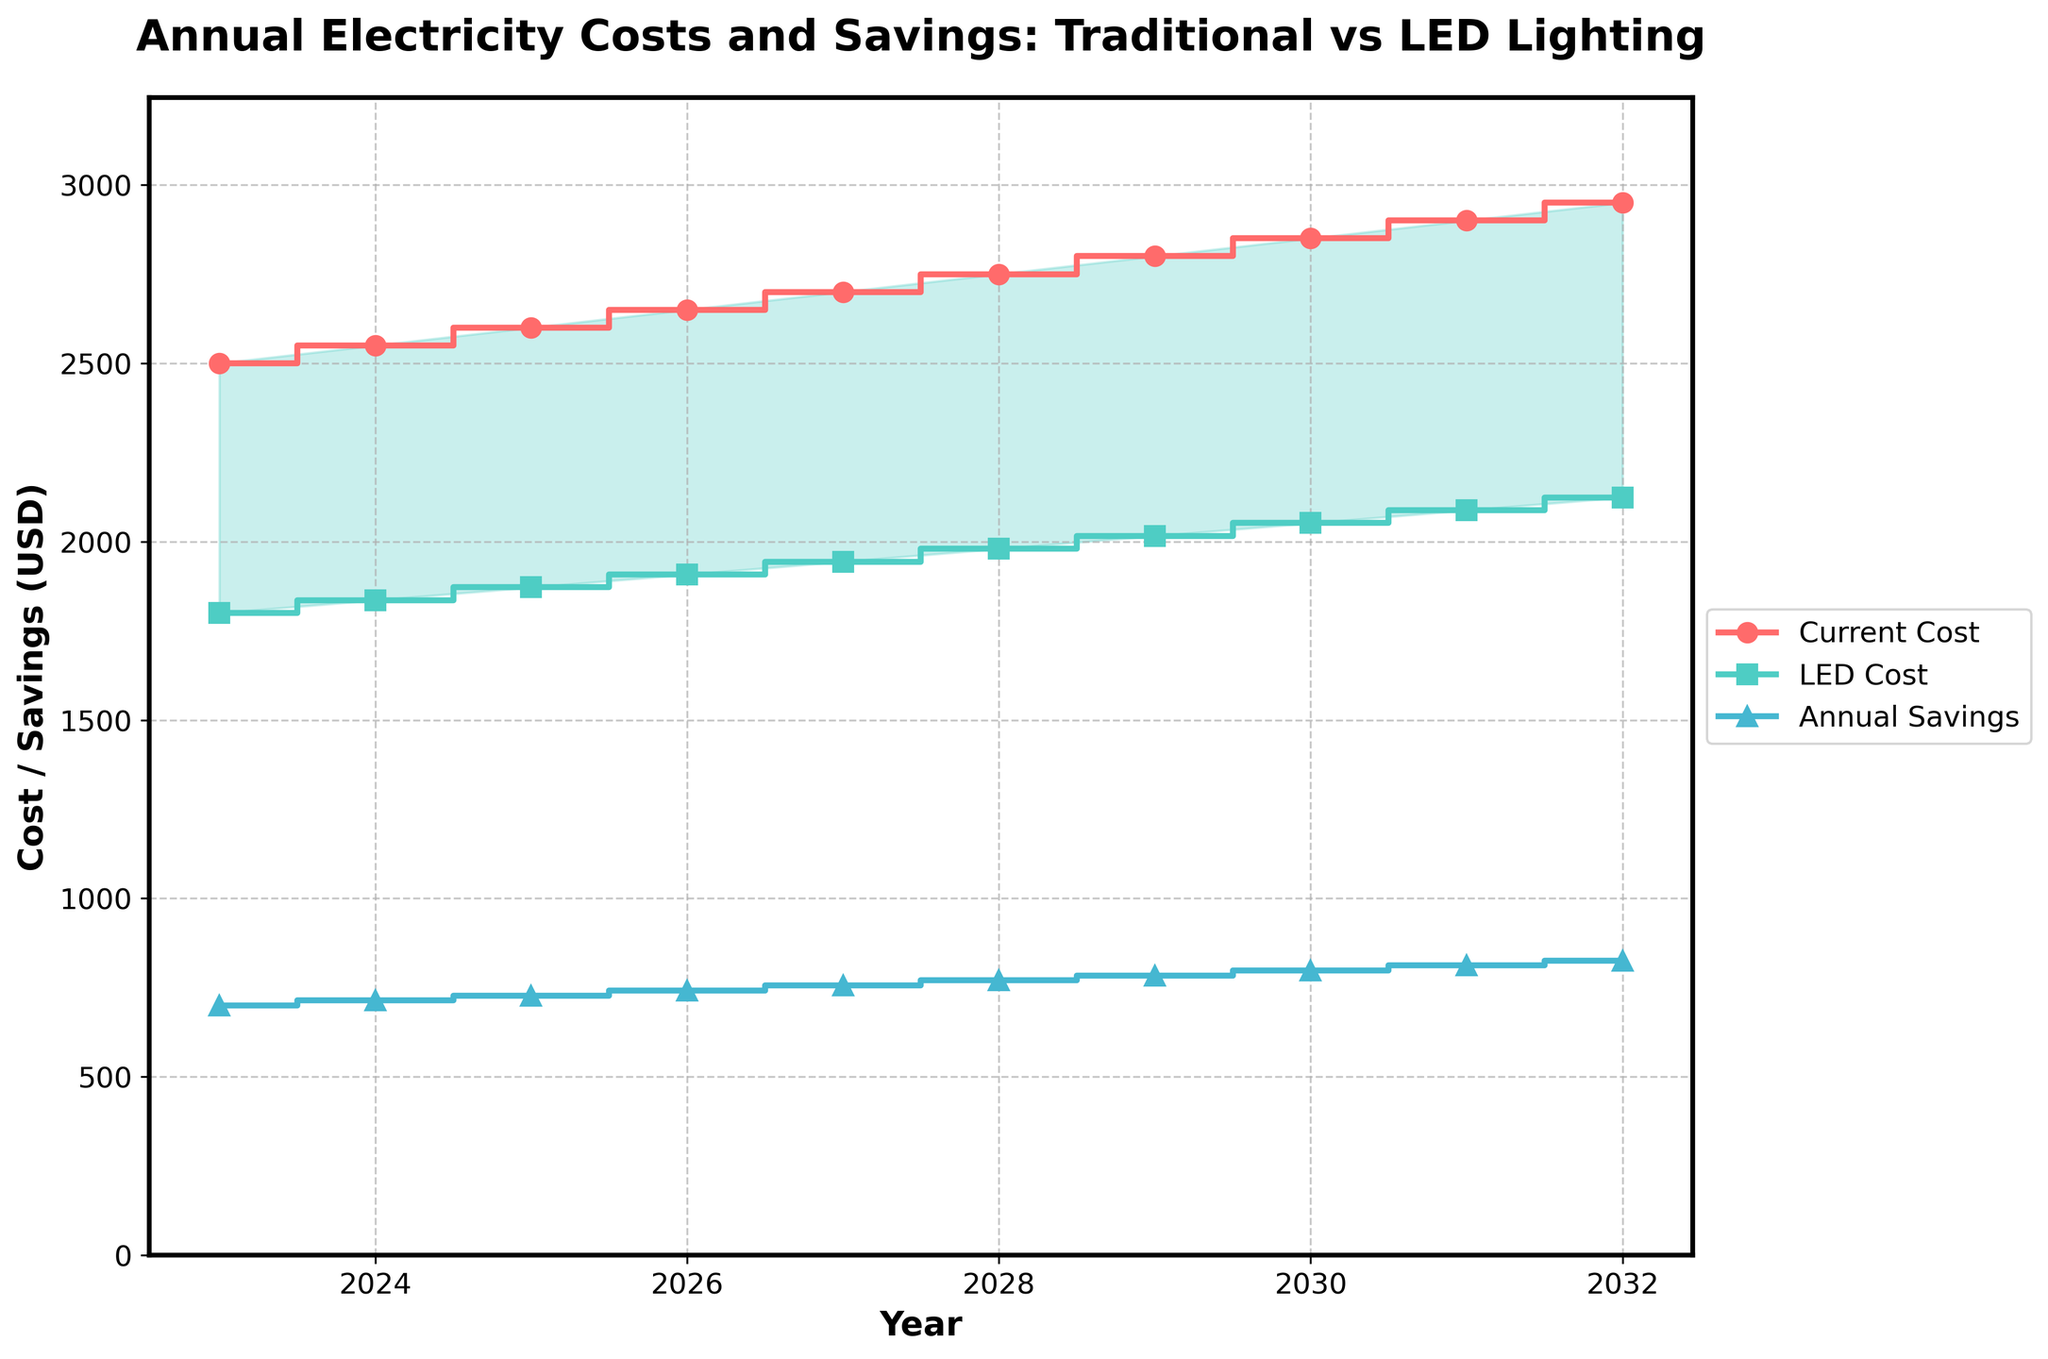What's the title of the figure? The title of the figure is displayed at the top of the plot. It is larger and in bold.
Answer: Annual Electricity Costs and Savings: Traditional vs LED Lighting How many years of data are shown in the plot? The x-axis represents the years and contains points from 2023 to 2032. To find the number of years, count these points. There are 10 years shown.
Answer: 10 What's the projected annual electricity cost with LED lighting in 2028? Locate the point on the LED cost line (represented with squares) corresponding to the year 2028. The y-axis value at this point is 1980.
Answer: 1980 What's the annual savings in the year 2025? Locate the point on the savings line (represented with triangles) corresponding to the year 2025. The y-axis value at this point is 728.
Answer: 728 What's the difference between the current cost and the LED cost in 2030? Identify the y-axis values for both the current cost (2850) and the LED cost (2052) in 2030 and subtract the LED cost from the current cost: 2850 - 2052.
Answer: 798 How do the annual savings change from 2023 to 2032? Observe the annual savings line over the years from 2023 to 2032. Notice that the line generally moves upward, indicating an increase. The savings rise from 700 in 2023 to 826 in 2032.
Answer: Increase Which year shows the highest current annual electricity cost? Locate the peak point on the current cost line (represented with circles). The highest point occurs at the end of the timeframe in 2032 with a value of 2950.
Answer: 2032 In which year is the projected annual electricity cost with LED lighting lowest? Identify the point on the LED cost line that lies lowest on the y-axis. The lowest projected cost is in 2023, valued at 1800.
Answer: 2023 What's the total savings from switching to LED lighting from 2023 to 2025? Sum the annual savings for the years 2023, 2024, and 2025: 700 + 714 + 728. The total savings over these three years are 2142.
Answer: 2142 By how much is the projected LED cost expected to increase from 2025 to 2030? Identify the LED cost values for 2025 and 2030, which are 1872 and 2052, respectively. Subtract the 2025 value from the 2030 value: 2052 - 1872.
Answer: 180 